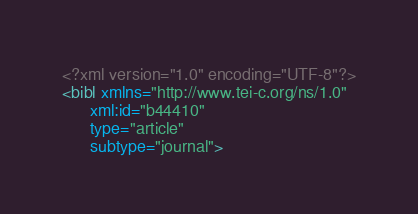<code> <loc_0><loc_0><loc_500><loc_500><_XML_><?xml version="1.0" encoding="UTF-8"?>
<bibl xmlns="http://www.tei-c.org/ns/1.0"
      xml:id="b44410"
      type="article"
      subtype="journal"></code> 